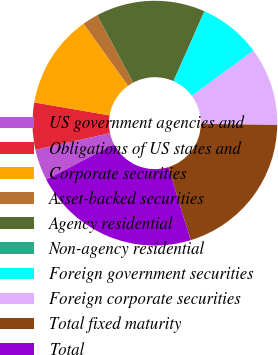Convert chart to OTSL. <chart><loc_0><loc_0><loc_500><loc_500><pie_chart><fcel>US government agencies and<fcel>Obligations of US states and<fcel>Corporate securities<fcel>Asset-backed securities<fcel>Agency residential<fcel>Non-agency residential<fcel>Foreign government securities<fcel>Foreign corporate securities<fcel>Total fixed maturity<fcel>Total<nl><fcel>4.14%<fcel>6.2%<fcel>12.39%<fcel>2.08%<fcel>14.45%<fcel>0.02%<fcel>8.26%<fcel>10.33%<fcel>20.04%<fcel>22.1%<nl></chart> 